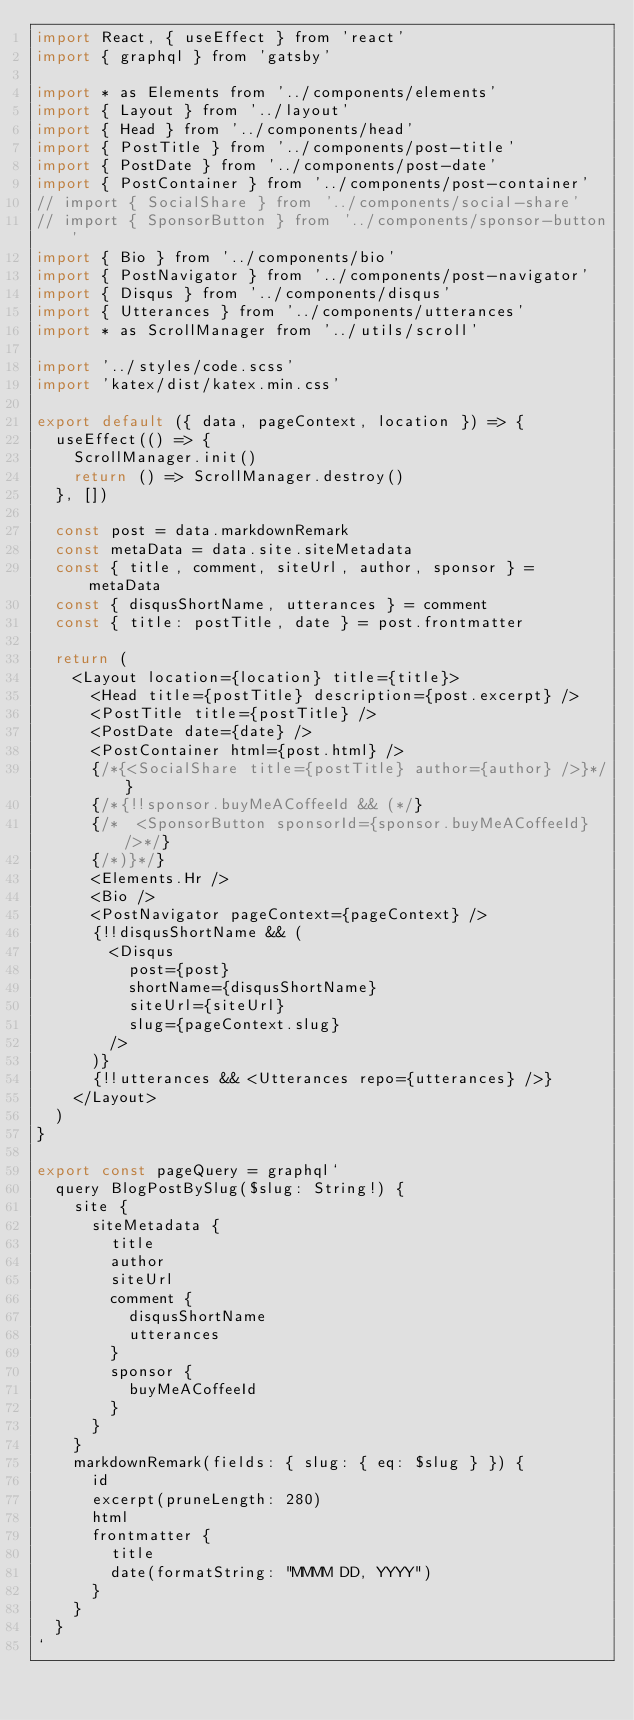Convert code to text. <code><loc_0><loc_0><loc_500><loc_500><_JavaScript_>import React, { useEffect } from 'react'
import { graphql } from 'gatsby'

import * as Elements from '../components/elements'
import { Layout } from '../layout'
import { Head } from '../components/head'
import { PostTitle } from '../components/post-title'
import { PostDate } from '../components/post-date'
import { PostContainer } from '../components/post-container'
// import { SocialShare } from '../components/social-share'
// import { SponsorButton } from '../components/sponsor-button'
import { Bio } from '../components/bio'
import { PostNavigator } from '../components/post-navigator'
import { Disqus } from '../components/disqus'
import { Utterances } from '../components/utterances'
import * as ScrollManager from '../utils/scroll'

import '../styles/code.scss'
import 'katex/dist/katex.min.css'

export default ({ data, pageContext, location }) => {
  useEffect(() => {
    ScrollManager.init()
    return () => ScrollManager.destroy()
  }, [])

  const post = data.markdownRemark
  const metaData = data.site.siteMetadata
  const { title, comment, siteUrl, author, sponsor } = metaData
  const { disqusShortName, utterances } = comment
  const { title: postTitle, date } = post.frontmatter

  return (
    <Layout location={location} title={title}>
      <Head title={postTitle} description={post.excerpt} />
      <PostTitle title={postTitle} />
      <PostDate date={date} />
      <PostContainer html={post.html} />
      {/*{<SocialShare title={postTitle} author={author} />}*/}
      {/*{!!sponsor.buyMeACoffeeId && (*/}
      {/*  <SponsorButton sponsorId={sponsor.buyMeACoffeeId} />*/}
      {/*)}*/}
      <Elements.Hr />
      <Bio />
      <PostNavigator pageContext={pageContext} />
      {!!disqusShortName && (
        <Disqus
          post={post}
          shortName={disqusShortName}
          siteUrl={siteUrl}
          slug={pageContext.slug}
        />
      )}
      {!!utterances && <Utterances repo={utterances} />}
    </Layout>
  )
}

export const pageQuery = graphql`
  query BlogPostBySlug($slug: String!) {
    site {
      siteMetadata {
        title
        author
        siteUrl
        comment {
          disqusShortName
          utterances
        }
        sponsor {
          buyMeACoffeeId
        }
      }
    }
    markdownRemark(fields: { slug: { eq: $slug } }) {
      id
      excerpt(pruneLength: 280)
      html
      frontmatter {
        title
        date(formatString: "MMMM DD, YYYY")
      }
    }
  }
`
</code> 